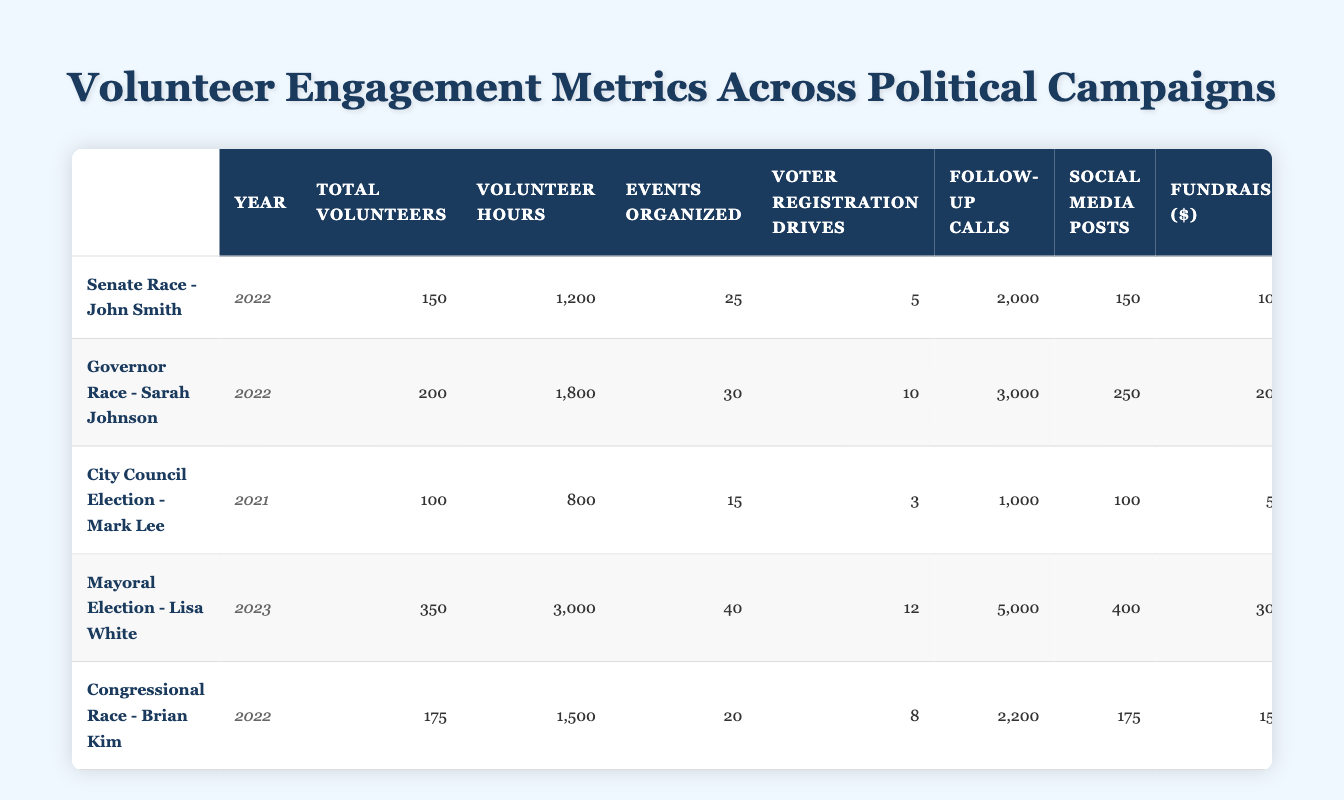What is the total number of volunteers in the Mayoral Election - Lisa White campaign? According to the table, the total number of volunteers for the Mayoral Election - Lisa White campaign is listed as 350.
Answer: 350 In which campaign was the highest number of volunteer hours contributed? Looking at the "Volunteer Hours Contributed" column, the highest value is 3000 hours, which corresponds to the Mayoral Election - Lisa White campaign.
Answer: Mayoral Election - Lisa White How many more fundraising dollars were raised in the Governor Race - Sarah Johnson compared to the City Council Election - Mark Lee? The fundraising effort for the Governor Race - Sarah Johnson is 20000 dollars, and for the City Council Election - Mark Lee, it is 5000 dollars. Subtracting these, 20000 - 5000 equals 15000 dollars.
Answer: 15000 Did the Congressional Race - Brian Kim organize more events than the Senate Race - John Smith? The table shows that the Congressional Race - Brian Kim organized 20 events and the Senate Race - John Smith organized 25 events. Since 20 is less than 25, the answer is no.
Answer: No What is the average number of volunteers across all campaigns listed in the table? To find the average number of volunteers, first sum the total volunteers: 150 + 200 + 100 + 350 + 175 = 1075. There are 5 campaigns, so the average is 1075 / 5 = 215.
Answer: 215 How many total follow-up calls were made across the Mayoral Election - Lisa White and the Congressional Race - Brian Kim? The Mayoral Election - Lisa White had 5000 follow-up calls and the Congressional Race - Brian Kim had 2200. Adding these gives 5000 + 2200 = 7200 total follow-up calls.
Answer: 7200 Is it true that the number of voter registration drives in the Governor Race - Sarah Johnson was greater than the total volunteers in the City Council Election - Mark Lee? The Governor Race - Sarah Johnson had 10 voter registration drives, while the City Council Election - Mark Lee had 100 total volunteers. Since 10 is not greater than 100, the answer is false.
Answer: False Which campaign had the most social media posts? In the "Social Media Posts" column, the Mayoral Election - Lisa White has the highest score with 400 posts.
Answer: Mayoral Election - Lisa White How does the total number of events organized in the Mayoral Election - Lisa White compare to the Senate Race - John Smith? The Mayoral Election - Lisa White organized 40 events while the Senate Race - John Smith organized 25 events. Since 40 is greater than 25, the Mayoral Election had more events organized.
Answer: More events organized 